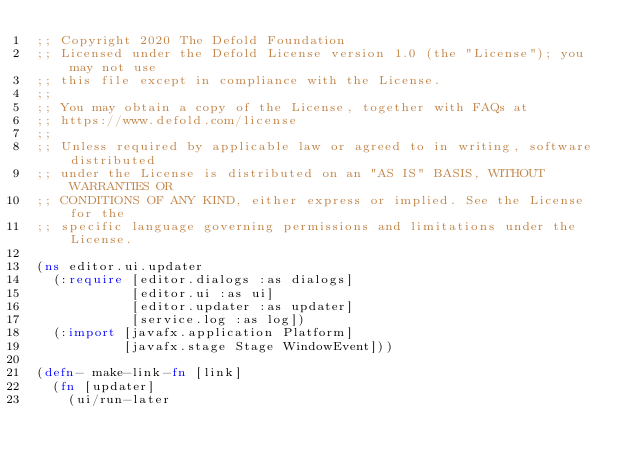Convert code to text. <code><loc_0><loc_0><loc_500><loc_500><_Clojure_>;; Copyright 2020 The Defold Foundation
;; Licensed under the Defold License version 1.0 (the "License"); you may not use
;; this file except in compliance with the License.
;; 
;; You may obtain a copy of the License, together with FAQs at
;; https://www.defold.com/license
;; 
;; Unless required by applicable law or agreed to in writing, software distributed
;; under the License is distributed on an "AS IS" BASIS, WITHOUT WARRANTIES OR
;; CONDITIONS OF ANY KIND, either express or implied. See the License for the
;; specific language governing permissions and limitations under the License.

(ns editor.ui.updater
  (:require [editor.dialogs :as dialogs]
            [editor.ui :as ui]
            [editor.updater :as updater]
            [service.log :as log])
  (:import [javafx.application Platform]
           [javafx.stage Stage WindowEvent]))

(defn- make-link-fn [link]
  (fn [updater]
    (ui/run-later</code> 